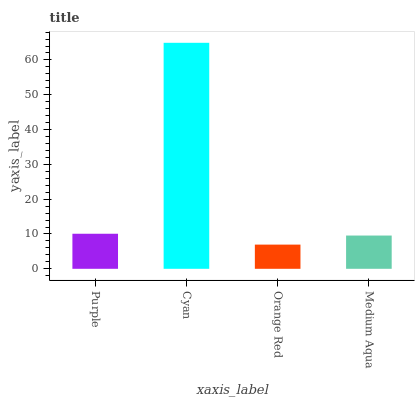Is Orange Red the minimum?
Answer yes or no. Yes. Is Cyan the maximum?
Answer yes or no. Yes. Is Cyan the minimum?
Answer yes or no. No. Is Orange Red the maximum?
Answer yes or no. No. Is Cyan greater than Orange Red?
Answer yes or no. Yes. Is Orange Red less than Cyan?
Answer yes or no. Yes. Is Orange Red greater than Cyan?
Answer yes or no. No. Is Cyan less than Orange Red?
Answer yes or no. No. Is Purple the high median?
Answer yes or no. Yes. Is Medium Aqua the low median?
Answer yes or no. Yes. Is Cyan the high median?
Answer yes or no. No. Is Orange Red the low median?
Answer yes or no. No. 